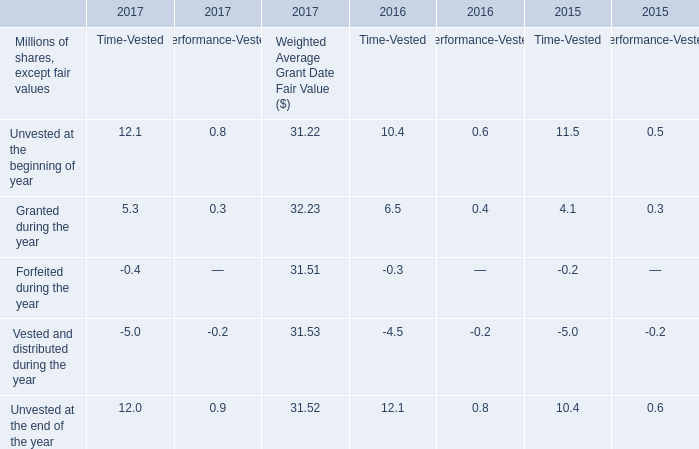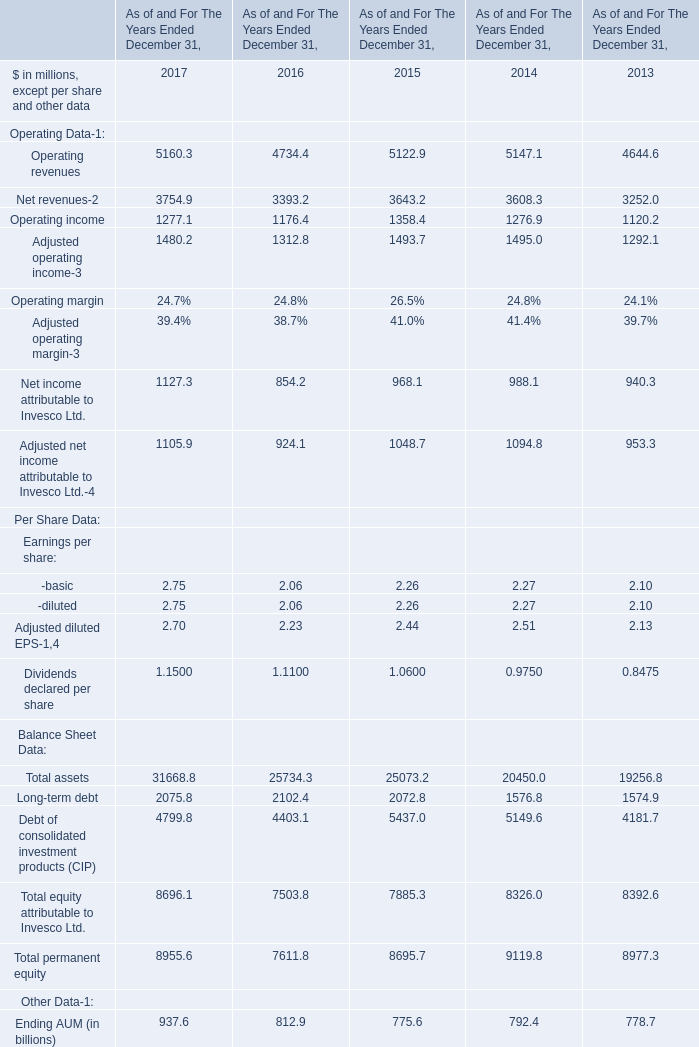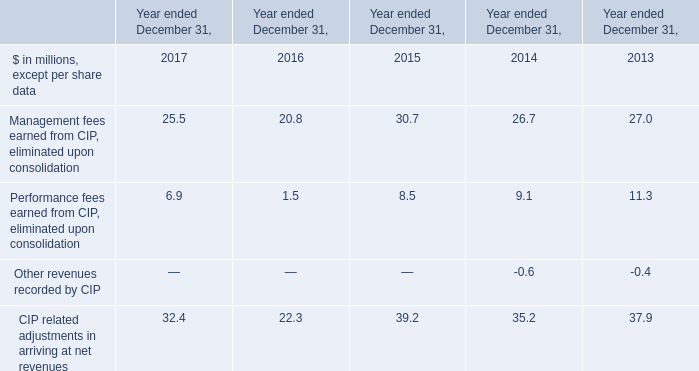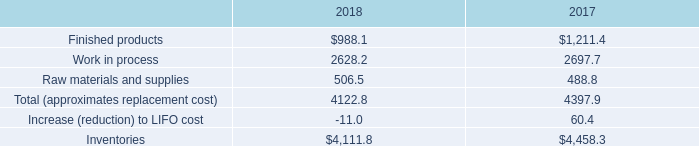What's the total amount of the Operating revenues in the years where Unvested at the beginning of year for Time-Vested is greater than 10? (in million) 
Computations: ((5160.3 + 4734.4) + 5122.9)
Answer: 15017.6. 